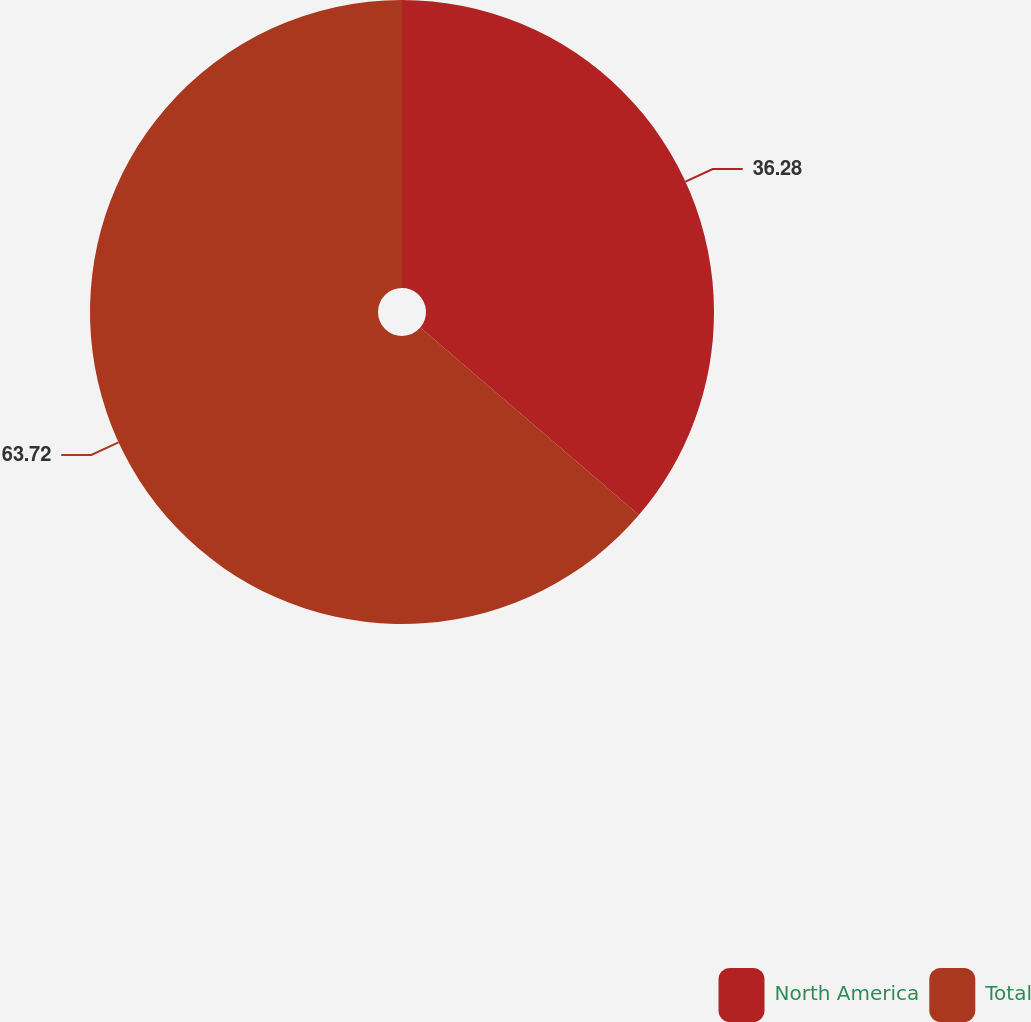Convert chart to OTSL. <chart><loc_0><loc_0><loc_500><loc_500><pie_chart><fcel>North America<fcel>Total<nl><fcel>36.28%<fcel>63.72%<nl></chart> 